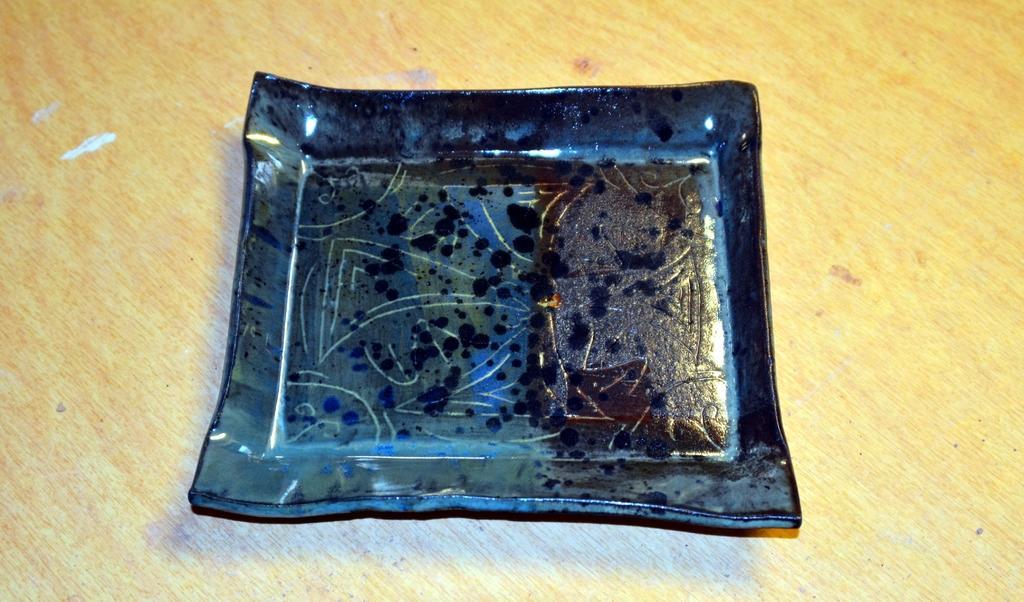Please provide a concise description of this image. In this picture we can see one plate is placed on the table. 